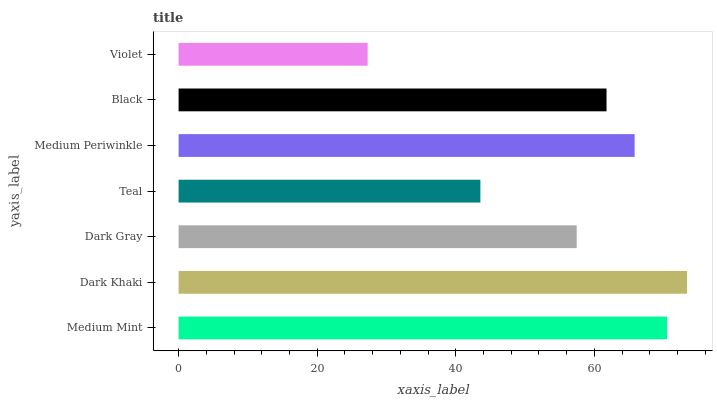Is Violet the minimum?
Answer yes or no. Yes. Is Dark Khaki the maximum?
Answer yes or no. Yes. Is Dark Gray the minimum?
Answer yes or no. No. Is Dark Gray the maximum?
Answer yes or no. No. Is Dark Khaki greater than Dark Gray?
Answer yes or no. Yes. Is Dark Gray less than Dark Khaki?
Answer yes or no. Yes. Is Dark Gray greater than Dark Khaki?
Answer yes or no. No. Is Dark Khaki less than Dark Gray?
Answer yes or no. No. Is Black the high median?
Answer yes or no. Yes. Is Black the low median?
Answer yes or no. Yes. Is Dark Gray the high median?
Answer yes or no. No. Is Medium Mint the low median?
Answer yes or no. No. 